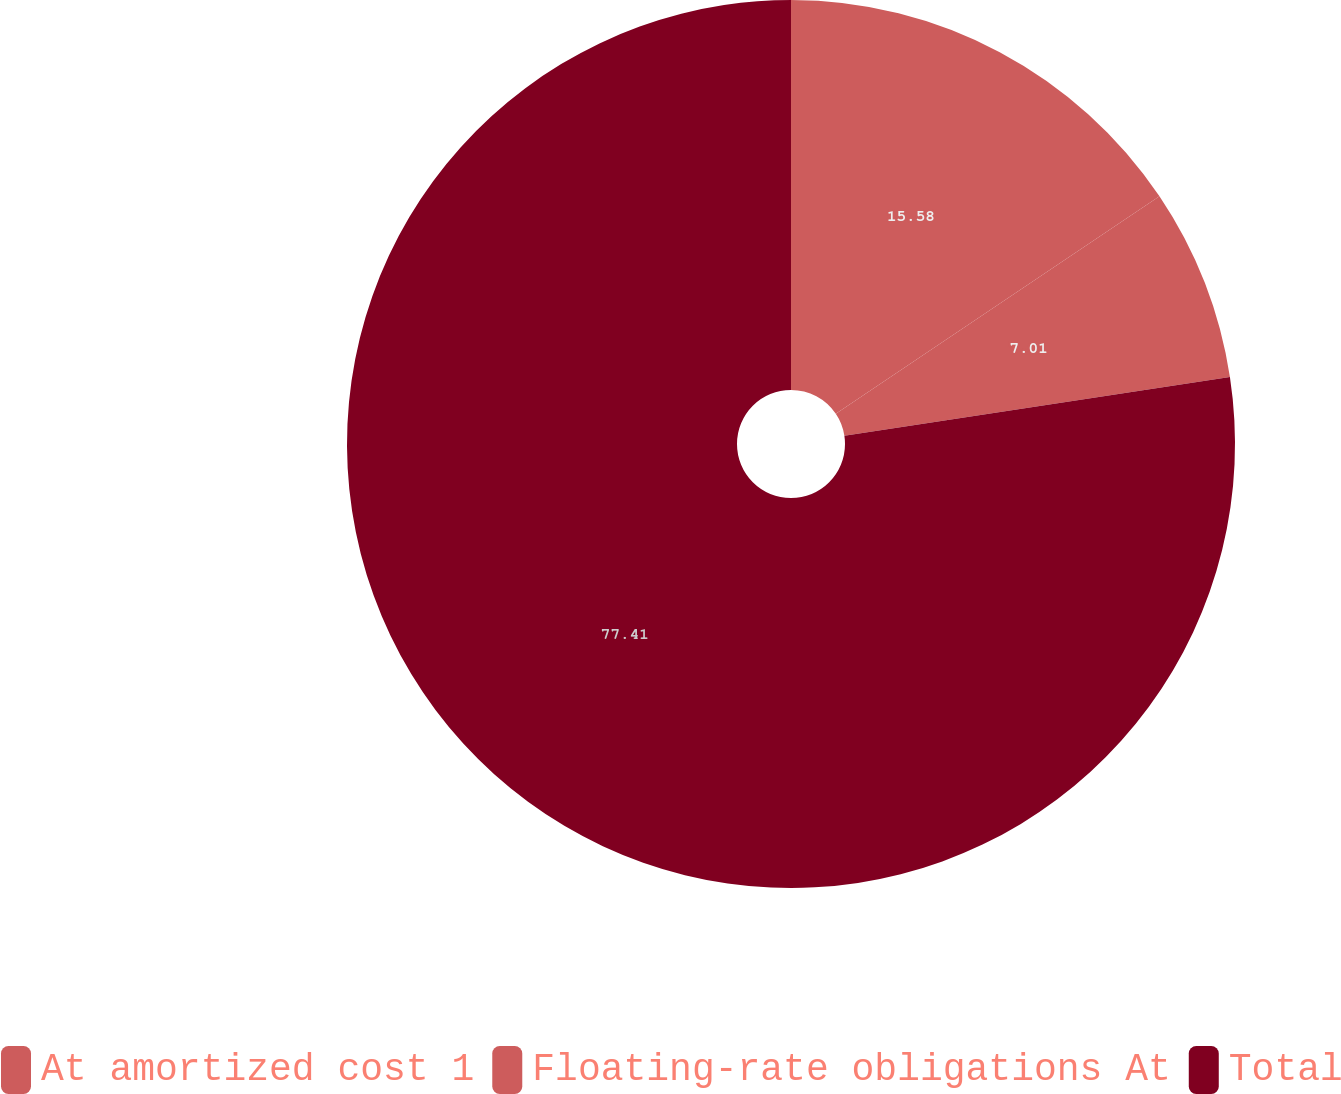Convert chart. <chart><loc_0><loc_0><loc_500><loc_500><pie_chart><fcel>At amortized cost 1<fcel>Floating-rate obligations At<fcel>Total<nl><fcel>15.58%<fcel>7.01%<fcel>77.41%<nl></chart> 